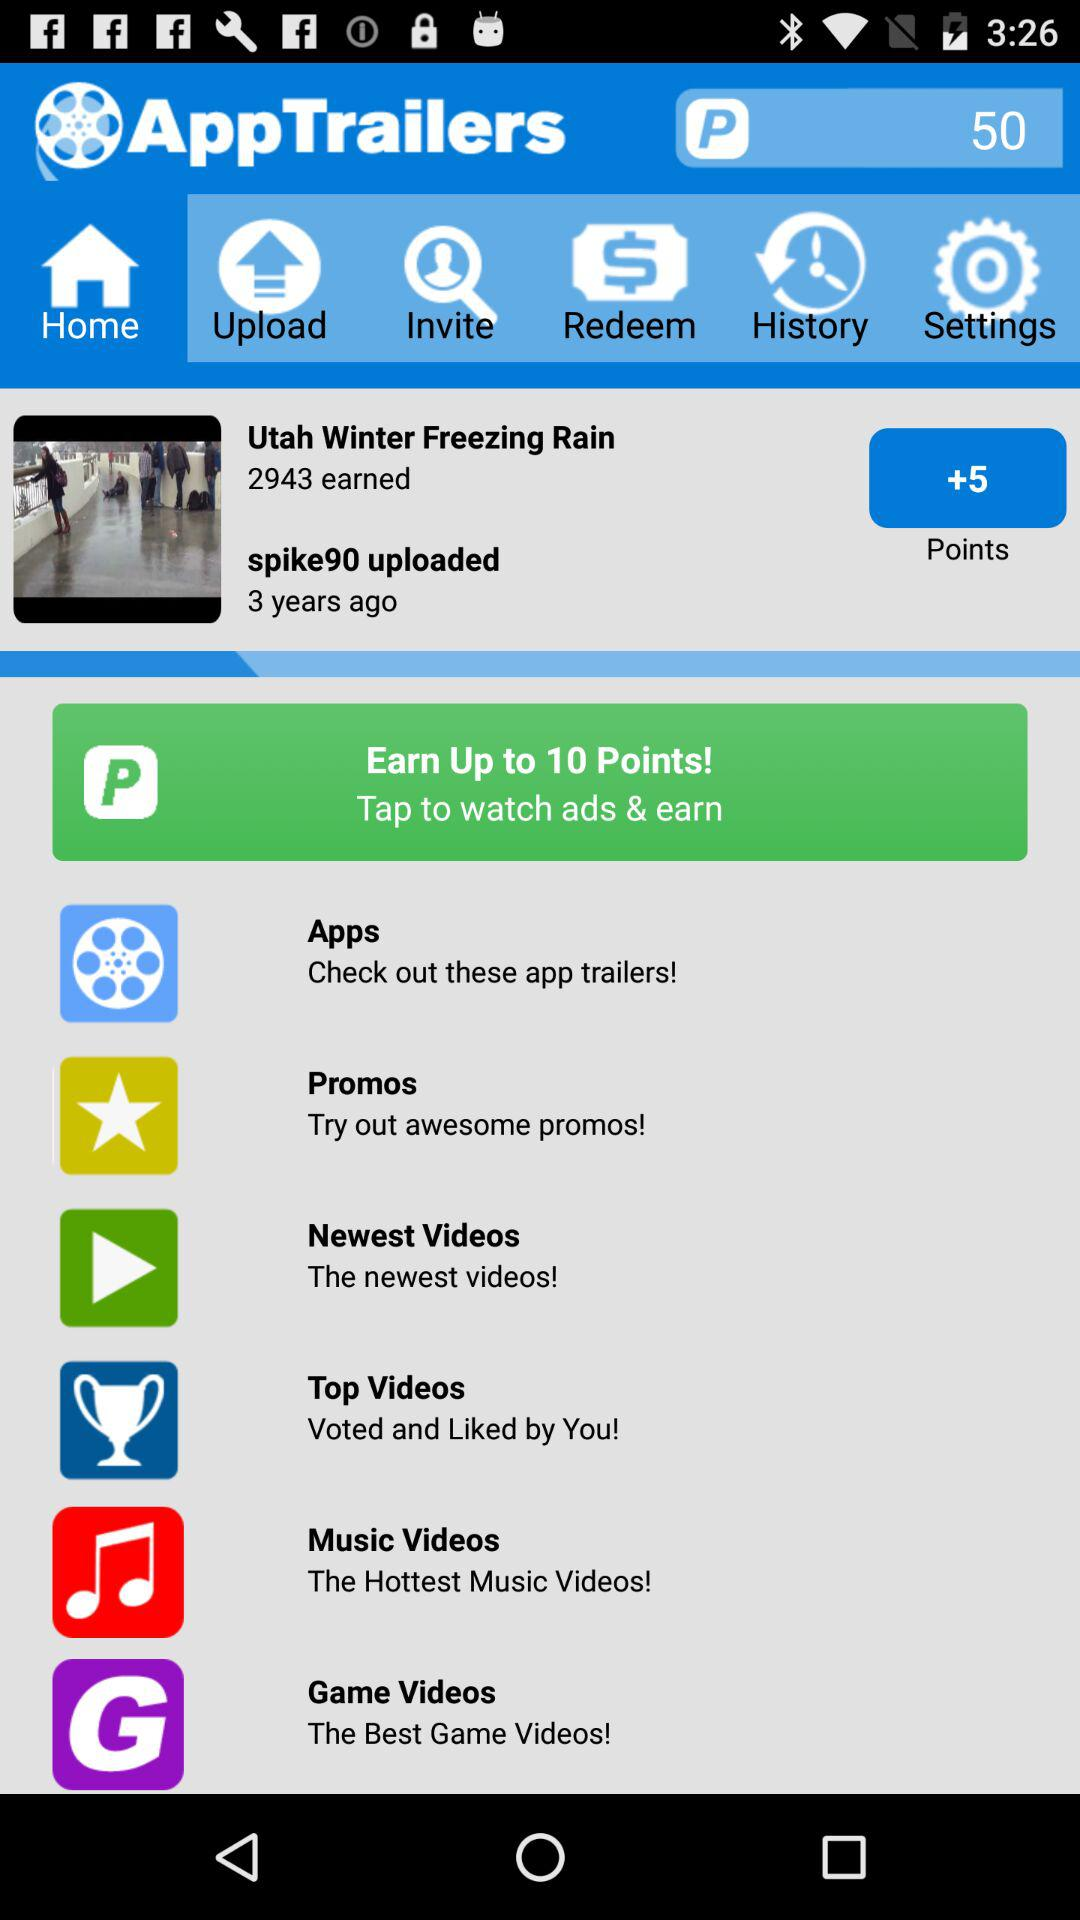How many points does the user have?
Answer the question using a single word or phrase. 2943 